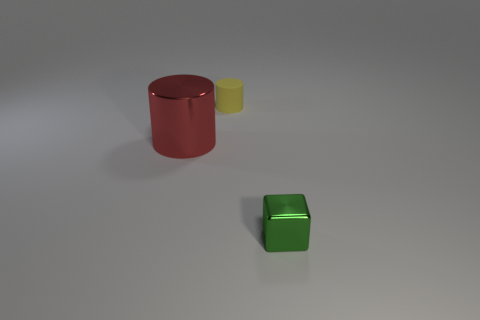There is a large cylinder that is the same material as the green block; what is its color?
Keep it short and to the point. Red. Does the green metal object have the same size as the cylinder in front of the small cylinder?
Offer a terse response. No. The yellow rubber thing has what shape?
Your answer should be very brief. Cylinder. How many other matte things have the same color as the tiny rubber thing?
Ensure brevity in your answer.  0. There is another small rubber thing that is the same shape as the red thing; what color is it?
Make the answer very short. Yellow. How many metallic things are to the left of the small green metallic object that is in front of the small cylinder?
Your answer should be compact. 1. How many blocks are either small things or small matte things?
Keep it short and to the point. 1. Are any tiny rubber cubes visible?
Ensure brevity in your answer.  No. What is the size of the other thing that is the same shape as the big object?
Your answer should be very brief. Small. What shape is the shiny thing that is to the right of the tiny thing that is to the left of the block?
Offer a very short reply. Cube. 